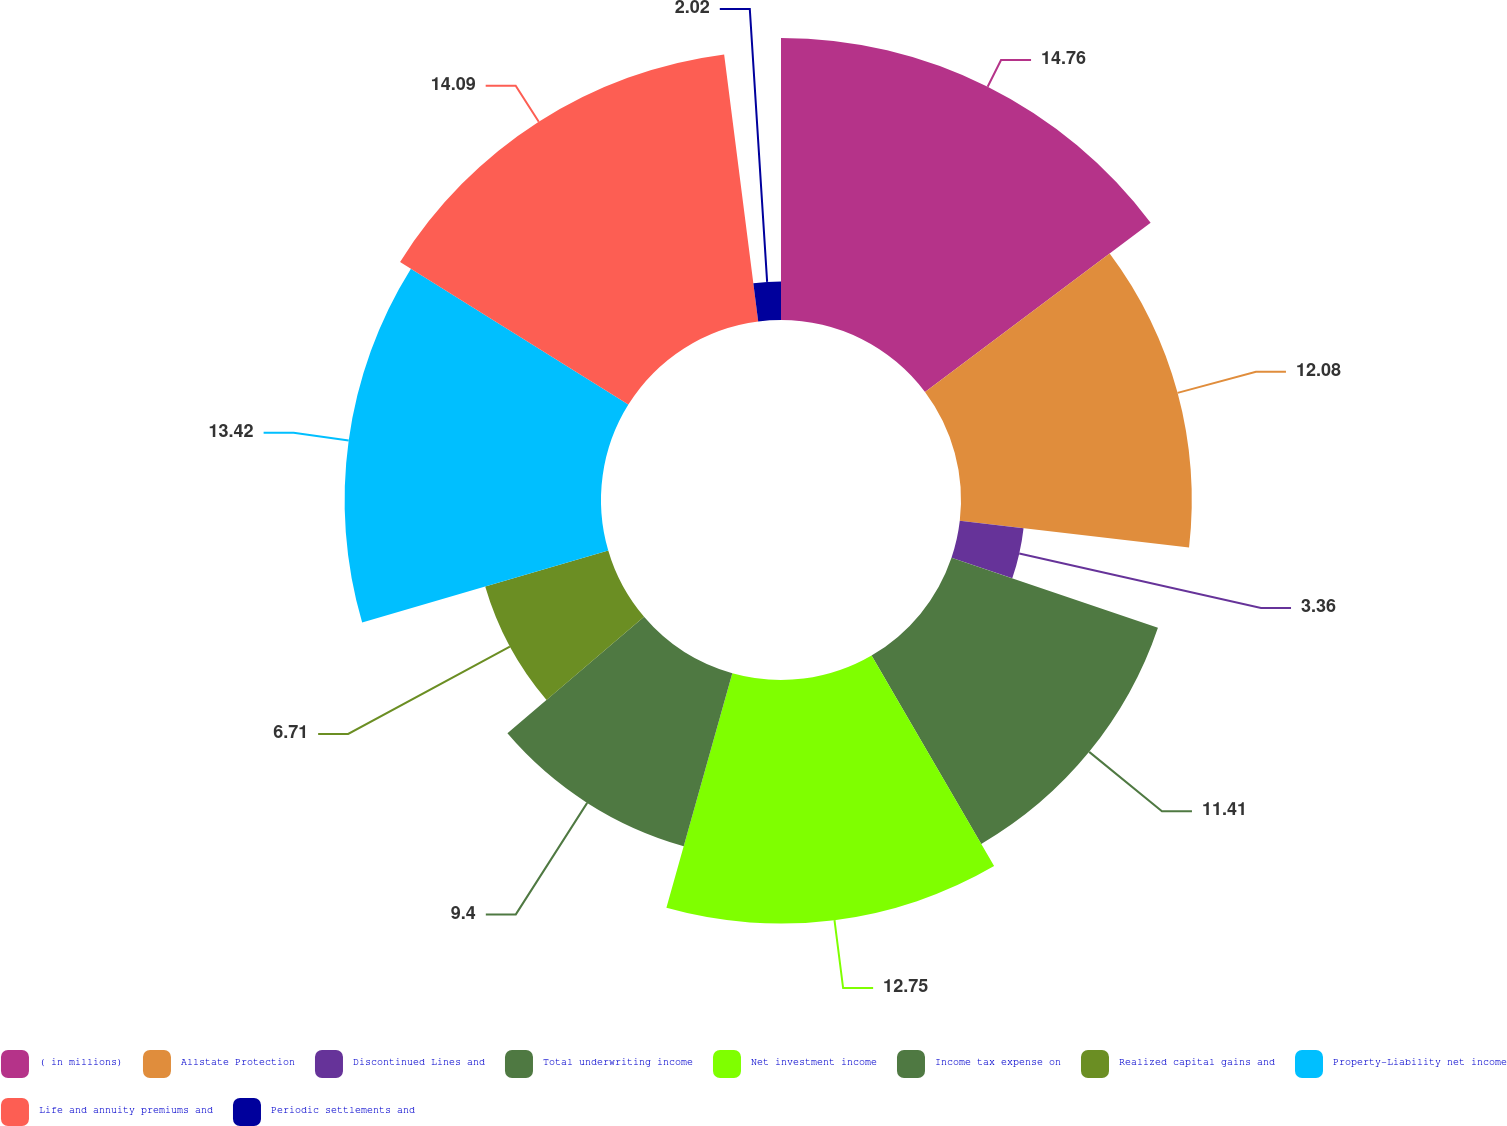Convert chart. <chart><loc_0><loc_0><loc_500><loc_500><pie_chart><fcel>( in millions)<fcel>Allstate Protection<fcel>Discontinued Lines and<fcel>Total underwriting income<fcel>Net investment income<fcel>Income tax expense on<fcel>Realized capital gains and<fcel>Property-Liability net income<fcel>Life and annuity premiums and<fcel>Periodic settlements and<nl><fcel>14.76%<fcel>12.08%<fcel>3.36%<fcel>11.41%<fcel>12.75%<fcel>9.4%<fcel>6.71%<fcel>13.42%<fcel>14.09%<fcel>2.02%<nl></chart> 